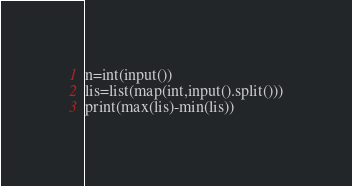Convert code to text. <code><loc_0><loc_0><loc_500><loc_500><_Python_>n=int(input())
lis=list(map(int,input().split()))
print(max(lis)-min(lis))</code> 